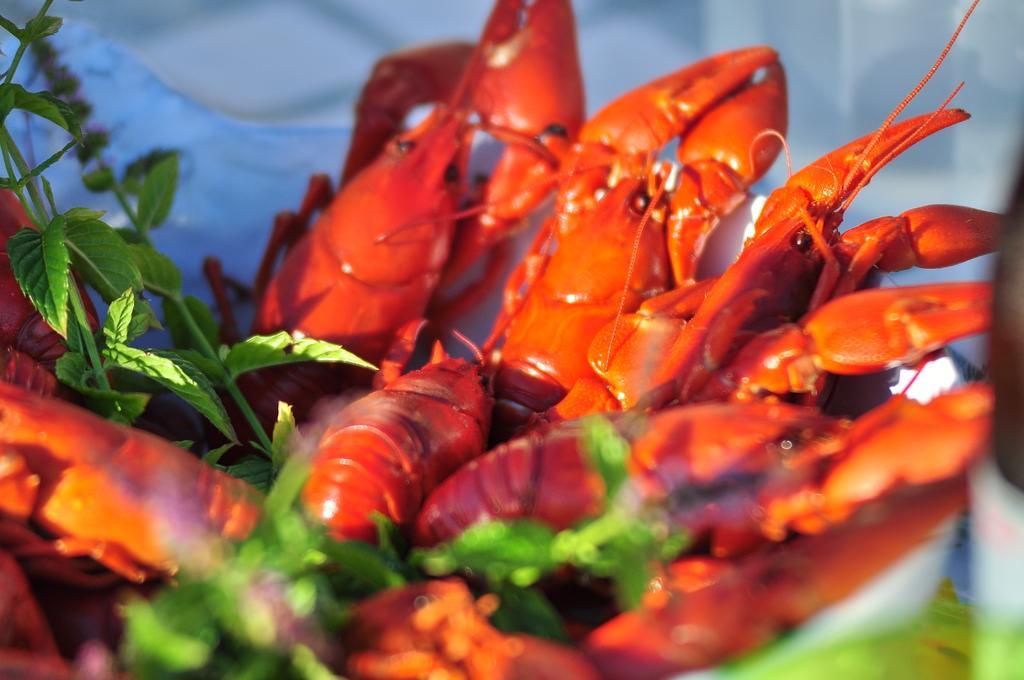Could you give a brief overview of what you see in this image? In this image these are a few lobsters and green leaves in the bowl. In this image the background is a little blurred. 